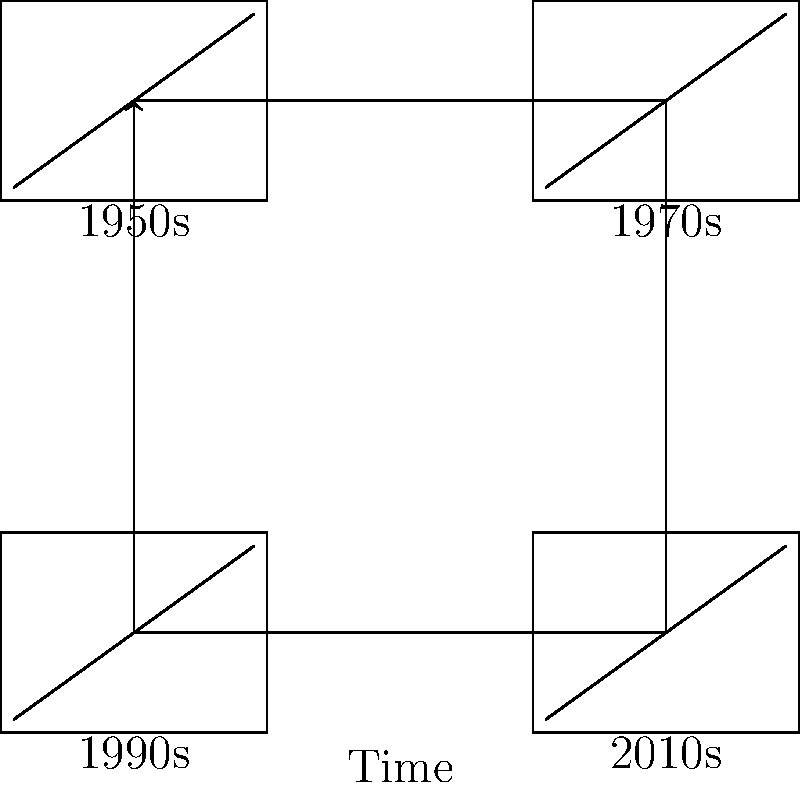As a historian with a passion for documentaries, analyze the evolution of television technology depicted in the timeline. Which technological advancement had the most significant impact on the quality and accessibility of documentary filmmaking? To answer this question, let's examine the evolution of television technology and its impact on documentary filmmaking:

1. 1950s: Early television sets were bulky and had small, low-resolution black and white screens. Documentaries were limited in their visual appeal and reach.

2. 1970s: Color television became widespread, allowing for more visually engaging documentaries. However, production and distribution were still costly and limited.

3. 1990s: The advent of cable television and satellite broadcasting expanded the reach of documentaries. Digital video cameras made production more accessible and affordable.

4. 2010s: High-definition and 4K televisions, coupled with streaming services, revolutionized both the quality and accessibility of documentaries. This era also saw the rise of user-generated content and social media platforms for distribution.

The most significant impact on documentary filmmaking came from the technological advancements of the 2010s. The combination of high-definition displays, digital production tools, and internet-based distribution platforms democratized documentary creation and viewing. This allowed for:

1. Higher quality visual content
2. More diverse and niche topics being covered
3. Global distribution through streaming services
4. Increased audience engagement and interaction

These factors collectively enhanced the quality of documentaries and made them more accessible to both creators and viewers worldwide.
Answer: Digital technology and internet-based distribution of the 2010s 